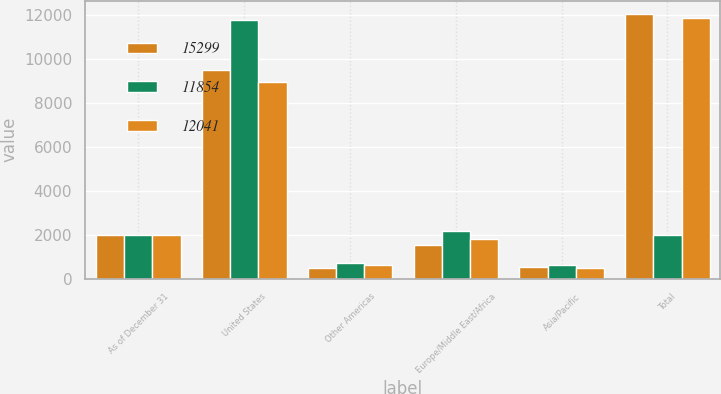Convert chart to OTSL. <chart><loc_0><loc_0><loc_500><loc_500><stacked_bar_chart><ecel><fcel>As of December 31<fcel>United States<fcel>Other Americas<fcel>Europe/Middle East/Africa<fcel>Asia/Pacific<fcel>Total<nl><fcel>15299<fcel>2008<fcel>9506<fcel>498<fcel>1524<fcel>513<fcel>12041<nl><fcel>11854<fcel>2007<fcel>11792<fcel>698<fcel>2163<fcel>646<fcel>2006<nl><fcel>12041<fcel>2006<fcel>8962<fcel>607<fcel>1815<fcel>470<fcel>11854<nl></chart> 